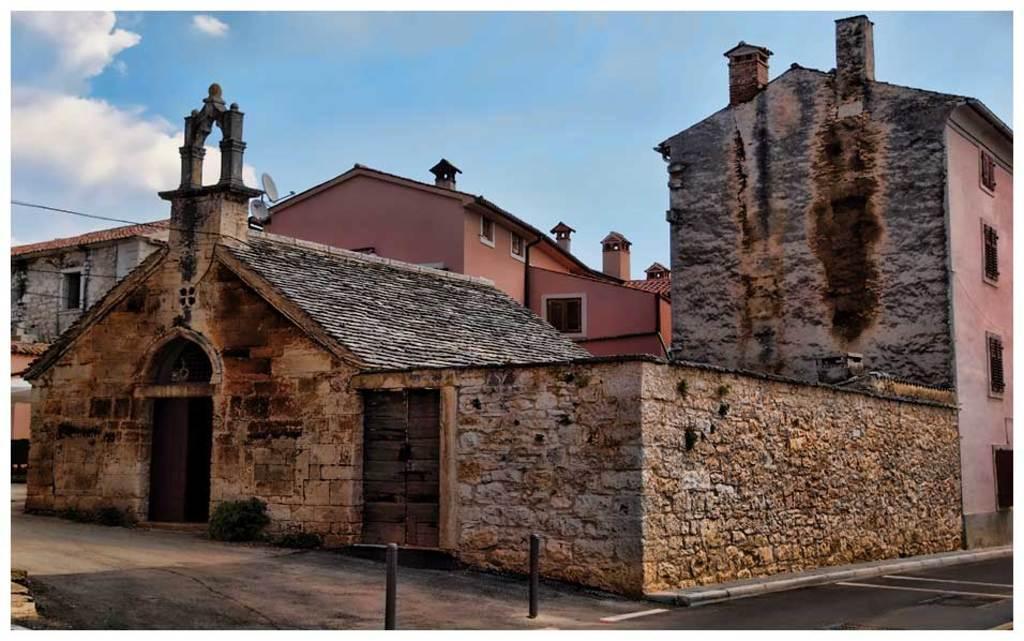In one or two sentences, can you explain what this image depicts? In this picture we can observe a building which is in brown color. There is another building which is in pink color. We can observe two black color poles and a road here. In the background there is a sky with clouds. 